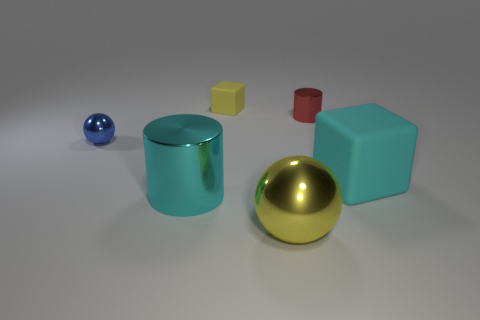Add 4 small blue metallic spheres. How many objects exist? 10 Subtract all cylinders. How many objects are left? 4 Subtract all small metal cylinders. Subtract all yellow metal balls. How many objects are left? 4 Add 3 tiny rubber blocks. How many tiny rubber blocks are left? 4 Add 1 large blue cylinders. How many large blue cylinders exist? 1 Subtract 0 blue blocks. How many objects are left? 6 